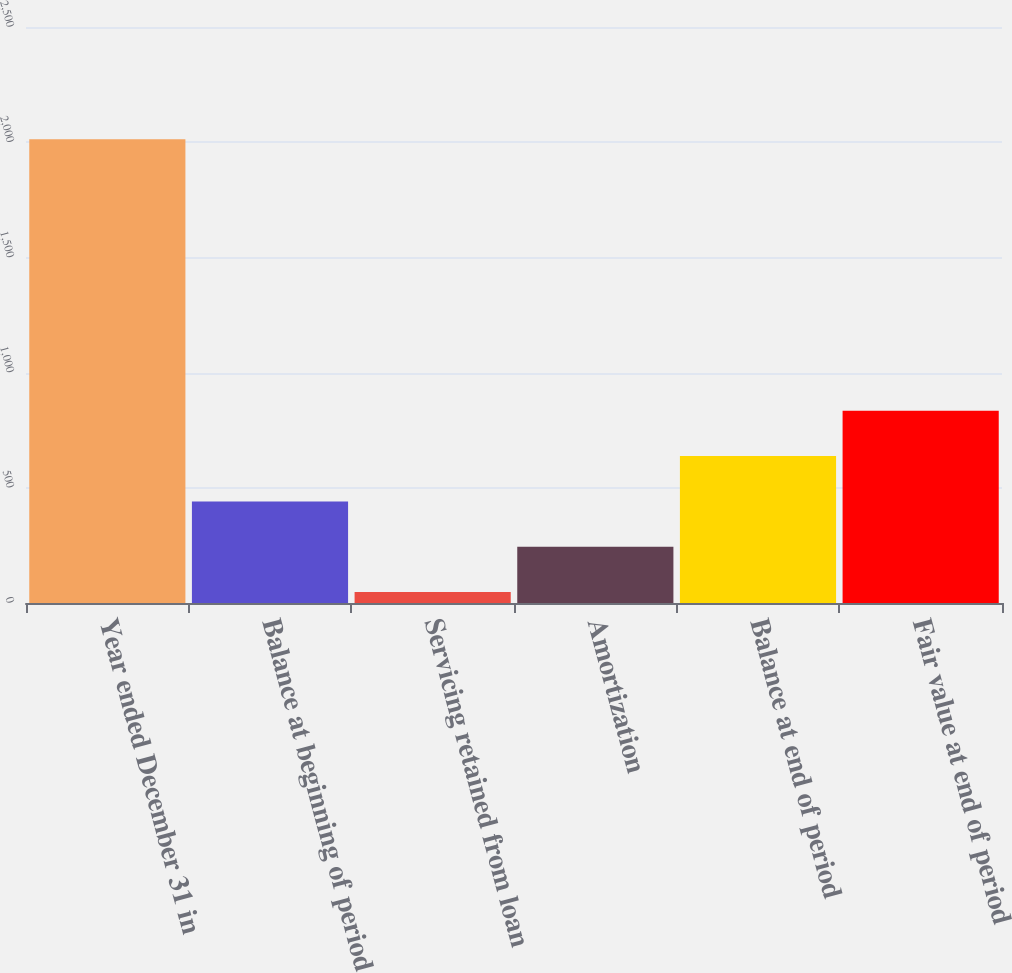<chart> <loc_0><loc_0><loc_500><loc_500><bar_chart><fcel>Year ended December 31 in<fcel>Balance at beginning of period<fcel>Servicing retained from loan<fcel>Amortization<fcel>Balance at end of period<fcel>Fair value at end of period<nl><fcel>2013<fcel>441<fcel>48<fcel>244.5<fcel>637.5<fcel>834<nl></chart> 